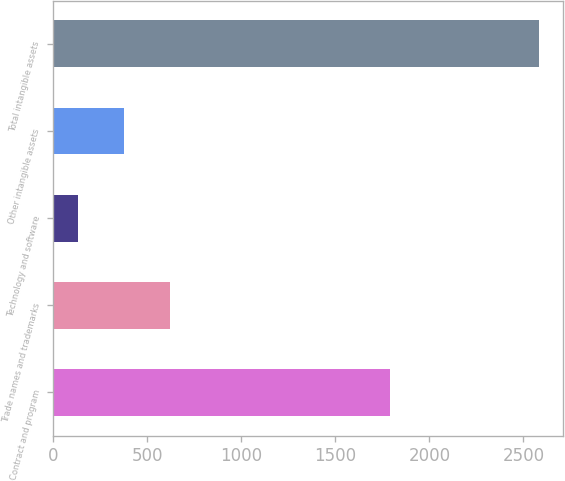Convert chart to OTSL. <chart><loc_0><loc_0><loc_500><loc_500><bar_chart><fcel>Contract and program<fcel>Trade names and trademarks<fcel>Technology and software<fcel>Other intangible assets<fcel>Total intangible assets<nl><fcel>1790<fcel>620.4<fcel>130<fcel>375.2<fcel>2582<nl></chart> 